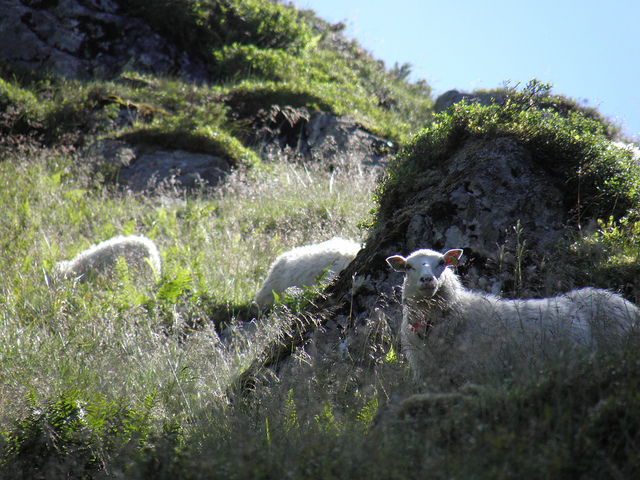How many sheep are in the photo? There are three sheep visible in the photo, each one grazing leisurely among the greenery of what appears to be a sunlit hillside. The tranquility of the scene is palpable, with the sheep appearing almost as natural components of the lush landscape. 